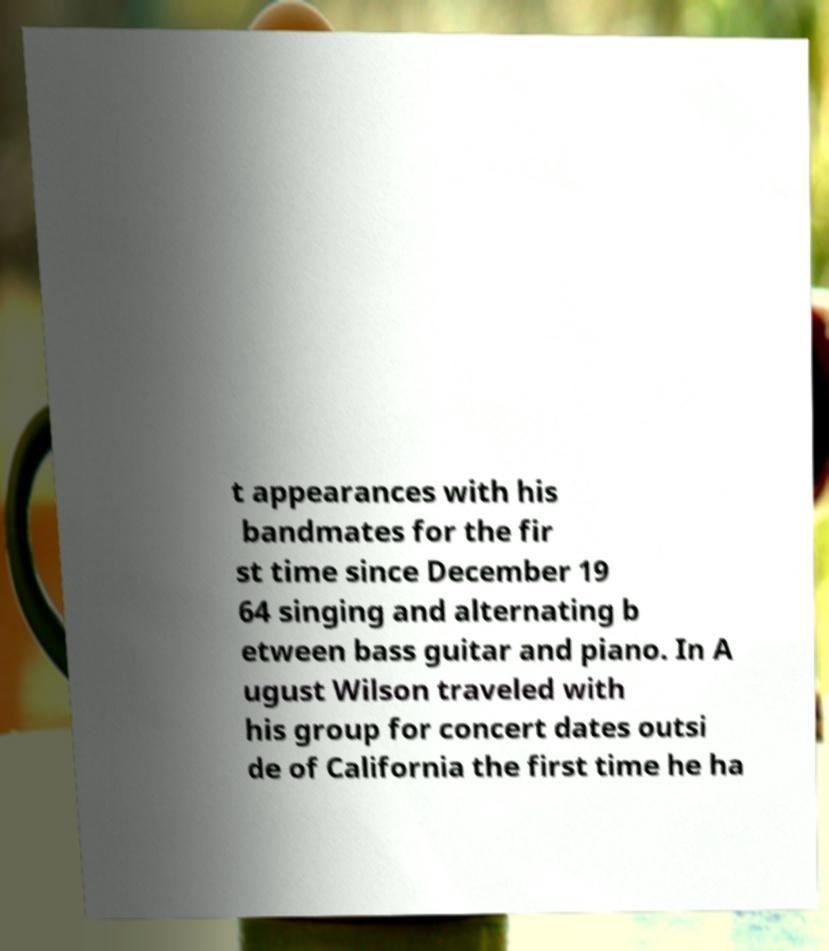For documentation purposes, I need the text within this image transcribed. Could you provide that? t appearances with his bandmates for the fir st time since December 19 64 singing and alternating b etween bass guitar and piano. In A ugust Wilson traveled with his group for concert dates outsi de of California the first time he ha 